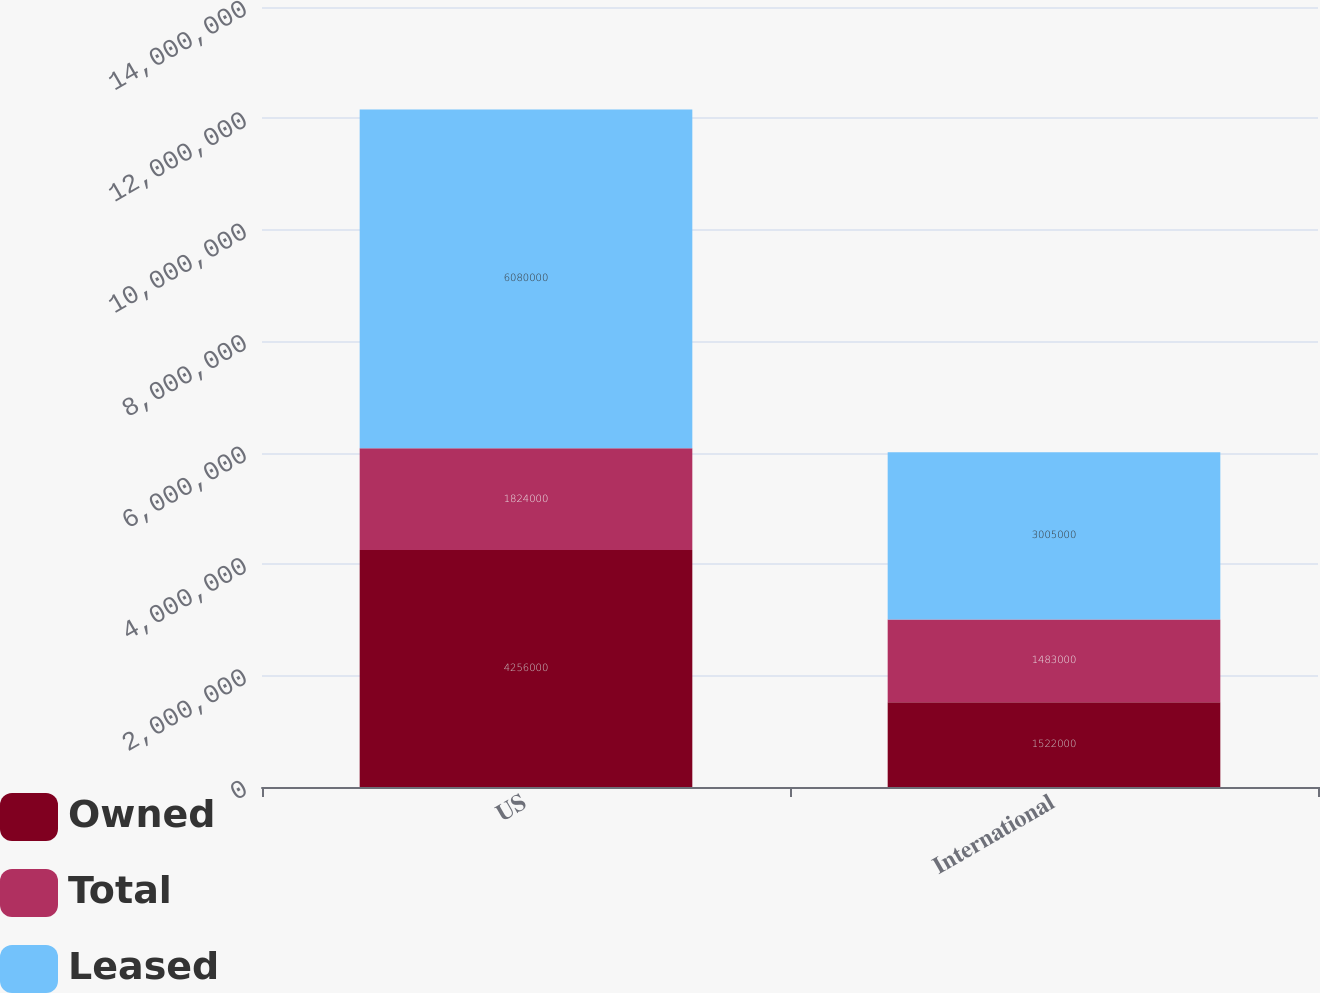Convert chart to OTSL. <chart><loc_0><loc_0><loc_500><loc_500><stacked_bar_chart><ecel><fcel>US<fcel>International<nl><fcel>Owned<fcel>4.256e+06<fcel>1.522e+06<nl><fcel>Total<fcel>1.824e+06<fcel>1.483e+06<nl><fcel>Leased<fcel>6.08e+06<fcel>3.005e+06<nl></chart> 